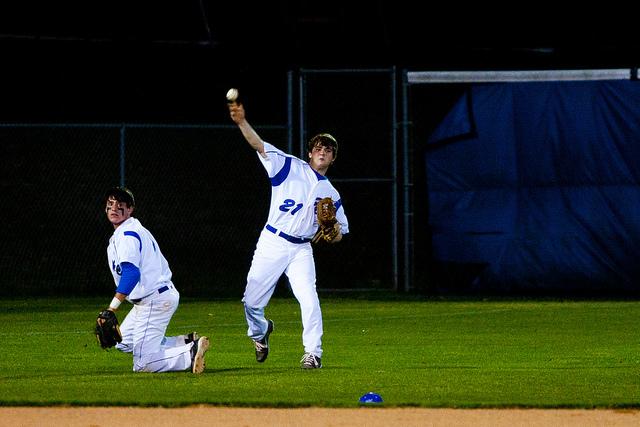Why is he on his knees?
Give a very brief answer. Fell. Do all of the visible players have their baseball glove on their left hand?
Be succinct. Yes. What position is the person in the forefront playing?
Keep it brief. Pitcher. Are these two people playing baseball?
Concise answer only. Yes. What number is on the players jersey?
Give a very brief answer. 21. What is the player holding?
Quick response, please. Glove. Are there any odd numbered jerseys?
Concise answer only. Yes. What team is this player on?
Give a very brief answer. Baseball team. Where is the baseball?
Give a very brief answer. In air. 